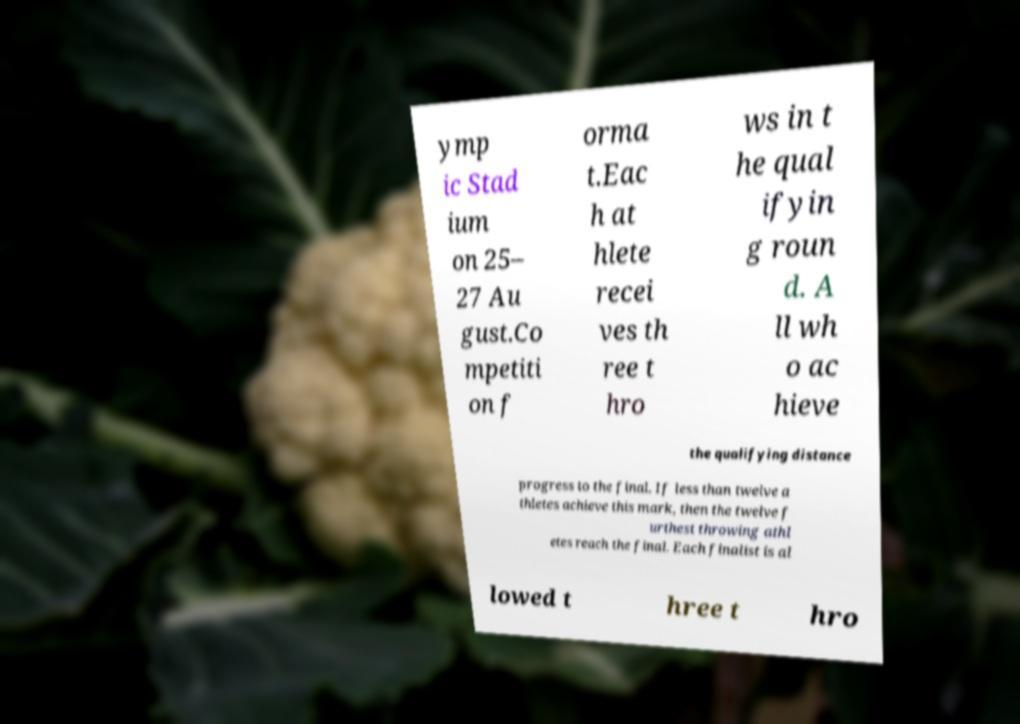Could you extract and type out the text from this image? ymp ic Stad ium on 25– 27 Au gust.Co mpetiti on f orma t.Eac h at hlete recei ves th ree t hro ws in t he qual ifyin g roun d. A ll wh o ac hieve the qualifying distance progress to the final. If less than twelve a thletes achieve this mark, then the twelve f urthest throwing athl etes reach the final. Each finalist is al lowed t hree t hro 